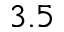Convert formula to latex. <formula><loc_0><loc_0><loc_500><loc_500>3 . 5</formula> 